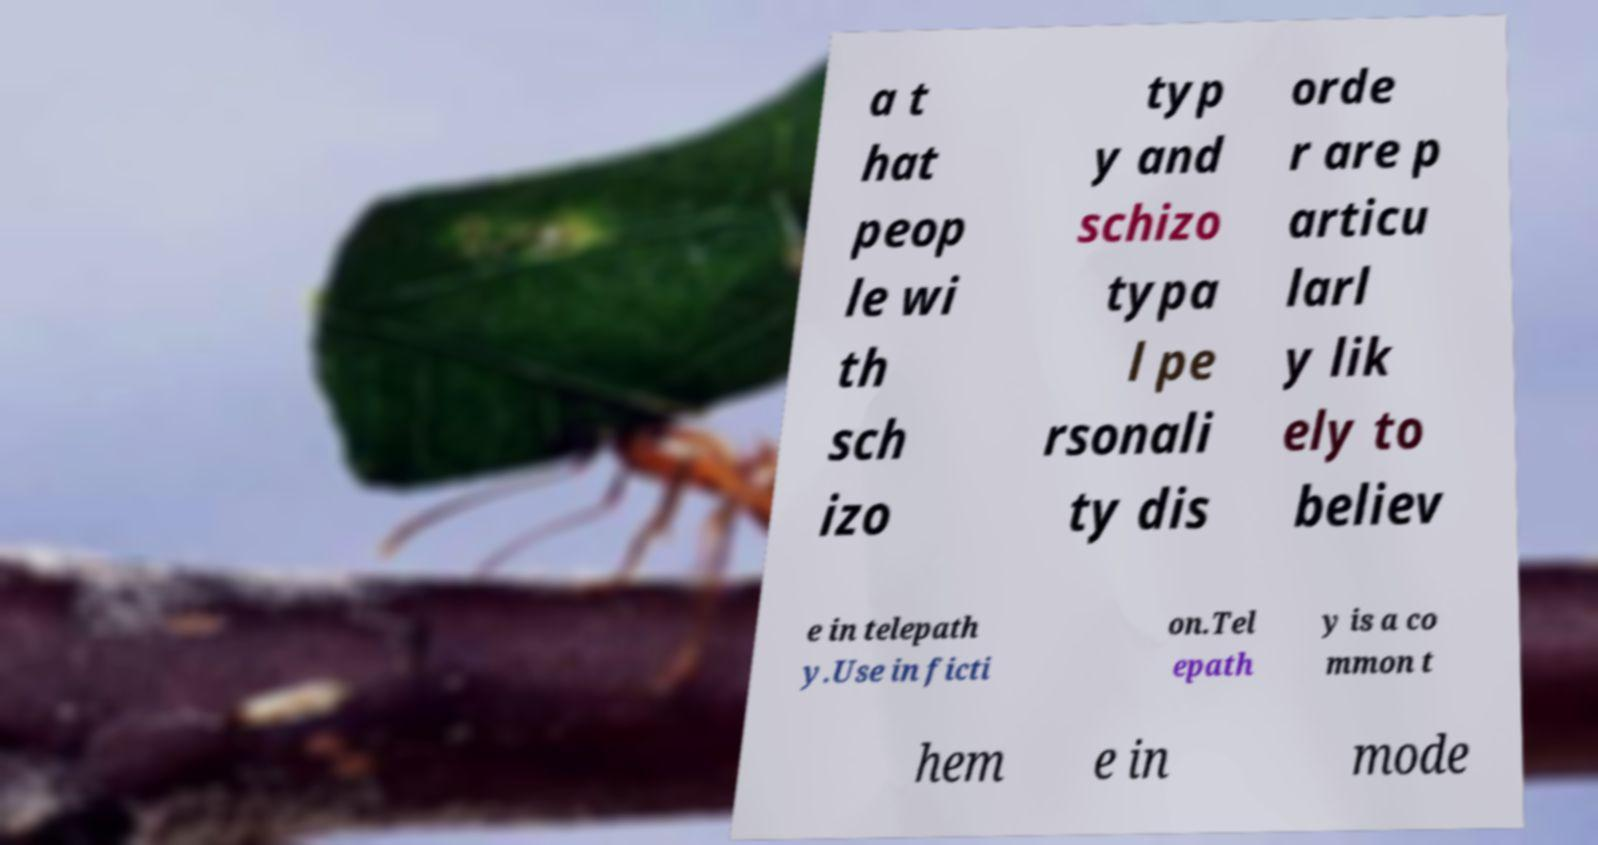Can you accurately transcribe the text from the provided image for me? a t hat peop le wi th sch izo typ y and schizo typa l pe rsonali ty dis orde r are p articu larl y lik ely to believ e in telepath y.Use in ficti on.Tel epath y is a co mmon t hem e in mode 